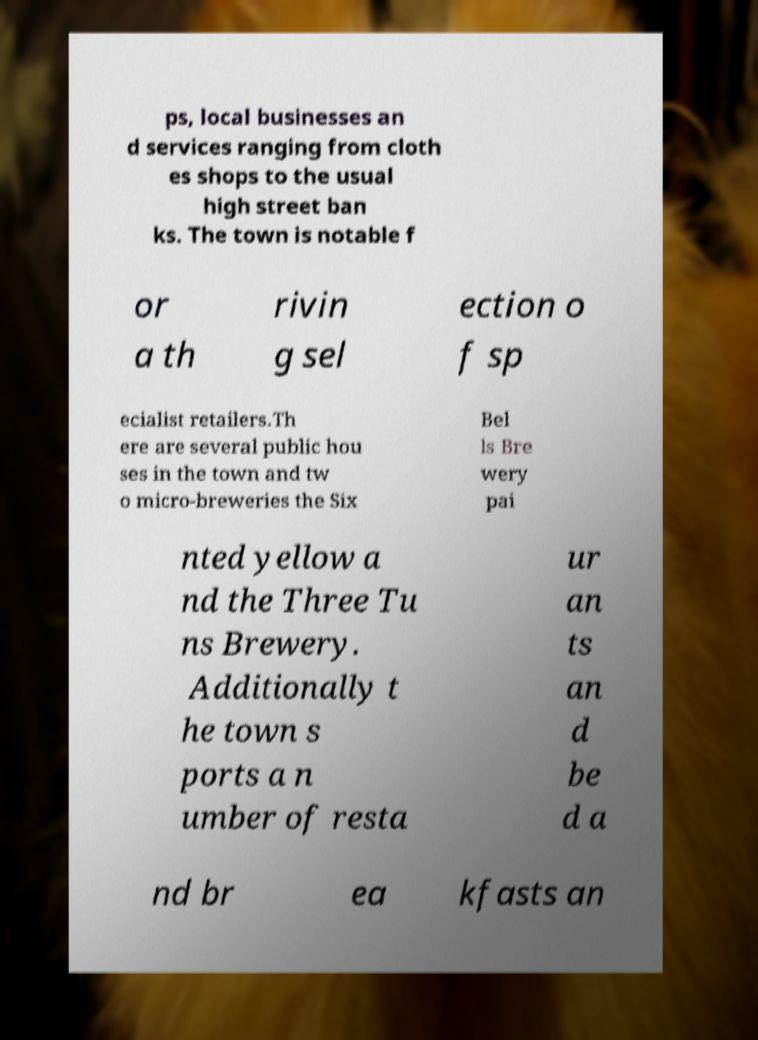Could you assist in decoding the text presented in this image and type it out clearly? ps, local businesses an d services ranging from cloth es shops to the usual high street ban ks. The town is notable f or a th rivin g sel ection o f sp ecialist retailers.Th ere are several public hou ses in the town and tw o micro-breweries the Six Bel ls Bre wery pai nted yellow a nd the Three Tu ns Brewery. Additionally t he town s ports a n umber of resta ur an ts an d be d a nd br ea kfasts an 